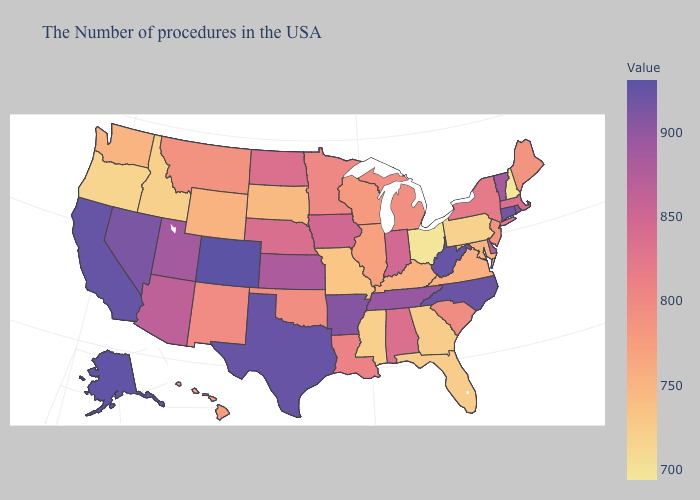Does Michigan have a lower value than Indiana?
Write a very short answer. Yes. Among the states that border Florida , which have the highest value?
Give a very brief answer. Alabama. Is the legend a continuous bar?
Answer briefly. Yes. Does Oregon have the highest value in the USA?
Concise answer only. No. 